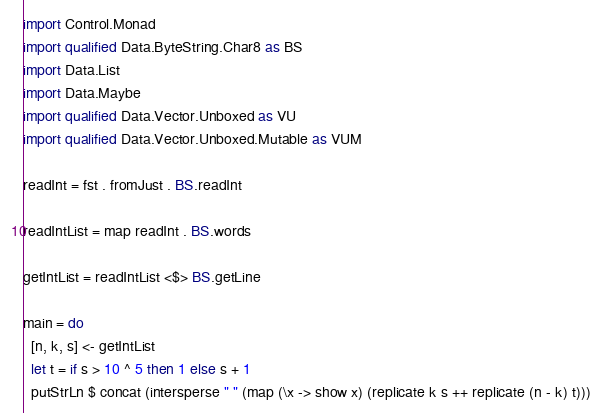Convert code to text. <code><loc_0><loc_0><loc_500><loc_500><_Haskell_>import Control.Monad
import qualified Data.ByteString.Char8 as BS
import Data.List
import Data.Maybe
import qualified Data.Vector.Unboxed as VU
import qualified Data.Vector.Unboxed.Mutable as VUM

readInt = fst . fromJust . BS.readInt

readIntList = map readInt . BS.words

getIntList = readIntList <$> BS.getLine

main = do
  [n, k, s] <- getIntList
  let t = if s > 10 ^ 5 then 1 else s + 1
  putStrLn $ concat (intersperse " " (map (\x -> show x) (replicate k s ++ replicate (n - k) t)))
</code> 